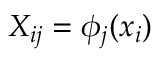<formula> <loc_0><loc_0><loc_500><loc_500>X _ { i j } = \phi _ { j } ( x _ { i } )</formula> 